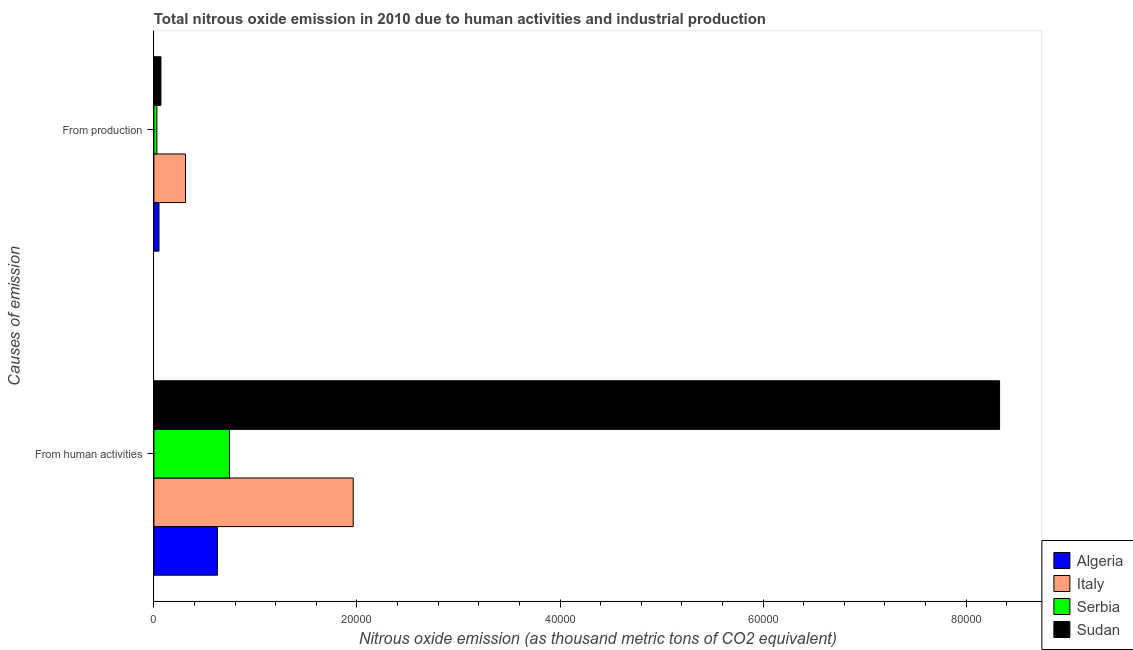How many groups of bars are there?
Give a very brief answer. 2. Are the number of bars on each tick of the Y-axis equal?
Make the answer very short. Yes. How many bars are there on the 2nd tick from the top?
Your answer should be compact. 4. What is the label of the 1st group of bars from the top?
Offer a terse response. From production. What is the amount of emissions from human activities in Algeria?
Give a very brief answer. 6256.9. Across all countries, what is the maximum amount of emissions generated from industries?
Give a very brief answer. 3117.9. Across all countries, what is the minimum amount of emissions from human activities?
Make the answer very short. 6256.9. In which country was the amount of emissions from human activities maximum?
Offer a very short reply. Sudan. In which country was the amount of emissions generated from industries minimum?
Your response must be concise. Serbia. What is the total amount of emissions generated from industries in the graph?
Your answer should be compact. 4610.5. What is the difference between the amount of emissions from human activities in Sudan and that in Serbia?
Provide a succinct answer. 7.58e+04. What is the difference between the amount of emissions from human activities in Italy and the amount of emissions generated from industries in Serbia?
Keep it short and to the point. 1.93e+04. What is the average amount of emissions generated from industries per country?
Your answer should be compact. 1152.62. What is the difference between the amount of emissions from human activities and amount of emissions generated from industries in Italy?
Your response must be concise. 1.65e+04. What is the ratio of the amount of emissions from human activities in Sudan to that in Serbia?
Keep it short and to the point. 11.19. In how many countries, is the amount of emissions generated from industries greater than the average amount of emissions generated from industries taken over all countries?
Your answer should be very brief. 1. What does the 4th bar from the top in From human activities represents?
Offer a very short reply. Algeria. How many bars are there?
Offer a terse response. 8. What is the difference between two consecutive major ticks on the X-axis?
Provide a short and direct response. 2.00e+04. Are the values on the major ticks of X-axis written in scientific E-notation?
Your answer should be very brief. No. How many legend labels are there?
Offer a terse response. 4. What is the title of the graph?
Give a very brief answer. Total nitrous oxide emission in 2010 due to human activities and industrial production. What is the label or title of the X-axis?
Your response must be concise. Nitrous oxide emission (as thousand metric tons of CO2 equivalent). What is the label or title of the Y-axis?
Your answer should be very brief. Causes of emission. What is the Nitrous oxide emission (as thousand metric tons of CO2 equivalent) in Algeria in From human activities?
Your response must be concise. 6256.9. What is the Nitrous oxide emission (as thousand metric tons of CO2 equivalent) of Italy in From human activities?
Your answer should be compact. 1.96e+04. What is the Nitrous oxide emission (as thousand metric tons of CO2 equivalent) in Serbia in From human activities?
Your answer should be very brief. 7444.9. What is the Nitrous oxide emission (as thousand metric tons of CO2 equivalent) in Sudan in From human activities?
Give a very brief answer. 8.33e+04. What is the Nitrous oxide emission (as thousand metric tons of CO2 equivalent) in Algeria in From production?
Make the answer very short. 501.9. What is the Nitrous oxide emission (as thousand metric tons of CO2 equivalent) in Italy in From production?
Ensure brevity in your answer.  3117.9. What is the Nitrous oxide emission (as thousand metric tons of CO2 equivalent) of Serbia in From production?
Make the answer very short. 296.1. What is the Nitrous oxide emission (as thousand metric tons of CO2 equivalent) of Sudan in From production?
Give a very brief answer. 694.6. Across all Causes of emission, what is the maximum Nitrous oxide emission (as thousand metric tons of CO2 equivalent) of Algeria?
Offer a terse response. 6256.9. Across all Causes of emission, what is the maximum Nitrous oxide emission (as thousand metric tons of CO2 equivalent) of Italy?
Keep it short and to the point. 1.96e+04. Across all Causes of emission, what is the maximum Nitrous oxide emission (as thousand metric tons of CO2 equivalent) of Serbia?
Provide a succinct answer. 7444.9. Across all Causes of emission, what is the maximum Nitrous oxide emission (as thousand metric tons of CO2 equivalent) of Sudan?
Offer a very short reply. 8.33e+04. Across all Causes of emission, what is the minimum Nitrous oxide emission (as thousand metric tons of CO2 equivalent) of Algeria?
Offer a very short reply. 501.9. Across all Causes of emission, what is the minimum Nitrous oxide emission (as thousand metric tons of CO2 equivalent) in Italy?
Your answer should be very brief. 3117.9. Across all Causes of emission, what is the minimum Nitrous oxide emission (as thousand metric tons of CO2 equivalent) of Serbia?
Your answer should be compact. 296.1. Across all Causes of emission, what is the minimum Nitrous oxide emission (as thousand metric tons of CO2 equivalent) of Sudan?
Keep it short and to the point. 694.6. What is the total Nitrous oxide emission (as thousand metric tons of CO2 equivalent) in Algeria in the graph?
Provide a succinct answer. 6758.8. What is the total Nitrous oxide emission (as thousand metric tons of CO2 equivalent) in Italy in the graph?
Provide a succinct answer. 2.27e+04. What is the total Nitrous oxide emission (as thousand metric tons of CO2 equivalent) of Serbia in the graph?
Keep it short and to the point. 7741. What is the total Nitrous oxide emission (as thousand metric tons of CO2 equivalent) in Sudan in the graph?
Make the answer very short. 8.40e+04. What is the difference between the Nitrous oxide emission (as thousand metric tons of CO2 equivalent) in Algeria in From human activities and that in From production?
Your answer should be very brief. 5755. What is the difference between the Nitrous oxide emission (as thousand metric tons of CO2 equivalent) in Italy in From human activities and that in From production?
Make the answer very short. 1.65e+04. What is the difference between the Nitrous oxide emission (as thousand metric tons of CO2 equivalent) of Serbia in From human activities and that in From production?
Offer a very short reply. 7148.8. What is the difference between the Nitrous oxide emission (as thousand metric tons of CO2 equivalent) in Sudan in From human activities and that in From production?
Offer a very short reply. 8.26e+04. What is the difference between the Nitrous oxide emission (as thousand metric tons of CO2 equivalent) in Algeria in From human activities and the Nitrous oxide emission (as thousand metric tons of CO2 equivalent) in Italy in From production?
Your answer should be very brief. 3139. What is the difference between the Nitrous oxide emission (as thousand metric tons of CO2 equivalent) in Algeria in From human activities and the Nitrous oxide emission (as thousand metric tons of CO2 equivalent) in Serbia in From production?
Make the answer very short. 5960.8. What is the difference between the Nitrous oxide emission (as thousand metric tons of CO2 equivalent) of Algeria in From human activities and the Nitrous oxide emission (as thousand metric tons of CO2 equivalent) of Sudan in From production?
Your response must be concise. 5562.3. What is the difference between the Nitrous oxide emission (as thousand metric tons of CO2 equivalent) in Italy in From human activities and the Nitrous oxide emission (as thousand metric tons of CO2 equivalent) in Serbia in From production?
Provide a short and direct response. 1.93e+04. What is the difference between the Nitrous oxide emission (as thousand metric tons of CO2 equivalent) in Italy in From human activities and the Nitrous oxide emission (as thousand metric tons of CO2 equivalent) in Sudan in From production?
Keep it short and to the point. 1.89e+04. What is the difference between the Nitrous oxide emission (as thousand metric tons of CO2 equivalent) in Serbia in From human activities and the Nitrous oxide emission (as thousand metric tons of CO2 equivalent) in Sudan in From production?
Offer a very short reply. 6750.3. What is the average Nitrous oxide emission (as thousand metric tons of CO2 equivalent) in Algeria per Causes of emission?
Your answer should be very brief. 3379.4. What is the average Nitrous oxide emission (as thousand metric tons of CO2 equivalent) of Italy per Causes of emission?
Your answer should be very brief. 1.14e+04. What is the average Nitrous oxide emission (as thousand metric tons of CO2 equivalent) in Serbia per Causes of emission?
Keep it short and to the point. 3870.5. What is the average Nitrous oxide emission (as thousand metric tons of CO2 equivalent) in Sudan per Causes of emission?
Offer a very short reply. 4.20e+04. What is the difference between the Nitrous oxide emission (as thousand metric tons of CO2 equivalent) of Algeria and Nitrous oxide emission (as thousand metric tons of CO2 equivalent) of Italy in From human activities?
Offer a terse response. -1.34e+04. What is the difference between the Nitrous oxide emission (as thousand metric tons of CO2 equivalent) of Algeria and Nitrous oxide emission (as thousand metric tons of CO2 equivalent) of Serbia in From human activities?
Make the answer very short. -1188. What is the difference between the Nitrous oxide emission (as thousand metric tons of CO2 equivalent) in Algeria and Nitrous oxide emission (as thousand metric tons of CO2 equivalent) in Sudan in From human activities?
Ensure brevity in your answer.  -7.70e+04. What is the difference between the Nitrous oxide emission (as thousand metric tons of CO2 equivalent) in Italy and Nitrous oxide emission (as thousand metric tons of CO2 equivalent) in Serbia in From human activities?
Provide a succinct answer. 1.22e+04. What is the difference between the Nitrous oxide emission (as thousand metric tons of CO2 equivalent) in Italy and Nitrous oxide emission (as thousand metric tons of CO2 equivalent) in Sudan in From human activities?
Your answer should be compact. -6.37e+04. What is the difference between the Nitrous oxide emission (as thousand metric tons of CO2 equivalent) in Serbia and Nitrous oxide emission (as thousand metric tons of CO2 equivalent) in Sudan in From human activities?
Your answer should be very brief. -7.58e+04. What is the difference between the Nitrous oxide emission (as thousand metric tons of CO2 equivalent) of Algeria and Nitrous oxide emission (as thousand metric tons of CO2 equivalent) of Italy in From production?
Make the answer very short. -2616. What is the difference between the Nitrous oxide emission (as thousand metric tons of CO2 equivalent) in Algeria and Nitrous oxide emission (as thousand metric tons of CO2 equivalent) in Serbia in From production?
Make the answer very short. 205.8. What is the difference between the Nitrous oxide emission (as thousand metric tons of CO2 equivalent) of Algeria and Nitrous oxide emission (as thousand metric tons of CO2 equivalent) of Sudan in From production?
Make the answer very short. -192.7. What is the difference between the Nitrous oxide emission (as thousand metric tons of CO2 equivalent) in Italy and Nitrous oxide emission (as thousand metric tons of CO2 equivalent) in Serbia in From production?
Your answer should be very brief. 2821.8. What is the difference between the Nitrous oxide emission (as thousand metric tons of CO2 equivalent) of Italy and Nitrous oxide emission (as thousand metric tons of CO2 equivalent) of Sudan in From production?
Provide a succinct answer. 2423.3. What is the difference between the Nitrous oxide emission (as thousand metric tons of CO2 equivalent) in Serbia and Nitrous oxide emission (as thousand metric tons of CO2 equivalent) in Sudan in From production?
Provide a short and direct response. -398.5. What is the ratio of the Nitrous oxide emission (as thousand metric tons of CO2 equivalent) of Algeria in From human activities to that in From production?
Your response must be concise. 12.47. What is the ratio of the Nitrous oxide emission (as thousand metric tons of CO2 equivalent) in Italy in From human activities to that in From production?
Provide a succinct answer. 6.3. What is the ratio of the Nitrous oxide emission (as thousand metric tons of CO2 equivalent) of Serbia in From human activities to that in From production?
Offer a terse response. 25.14. What is the ratio of the Nitrous oxide emission (as thousand metric tons of CO2 equivalent) in Sudan in From human activities to that in From production?
Make the answer very short. 119.92. What is the difference between the highest and the second highest Nitrous oxide emission (as thousand metric tons of CO2 equivalent) in Algeria?
Give a very brief answer. 5755. What is the difference between the highest and the second highest Nitrous oxide emission (as thousand metric tons of CO2 equivalent) in Italy?
Provide a succinct answer. 1.65e+04. What is the difference between the highest and the second highest Nitrous oxide emission (as thousand metric tons of CO2 equivalent) of Serbia?
Offer a very short reply. 7148.8. What is the difference between the highest and the second highest Nitrous oxide emission (as thousand metric tons of CO2 equivalent) in Sudan?
Your response must be concise. 8.26e+04. What is the difference between the highest and the lowest Nitrous oxide emission (as thousand metric tons of CO2 equivalent) in Algeria?
Offer a terse response. 5755. What is the difference between the highest and the lowest Nitrous oxide emission (as thousand metric tons of CO2 equivalent) of Italy?
Keep it short and to the point. 1.65e+04. What is the difference between the highest and the lowest Nitrous oxide emission (as thousand metric tons of CO2 equivalent) in Serbia?
Ensure brevity in your answer.  7148.8. What is the difference between the highest and the lowest Nitrous oxide emission (as thousand metric tons of CO2 equivalent) in Sudan?
Provide a succinct answer. 8.26e+04. 